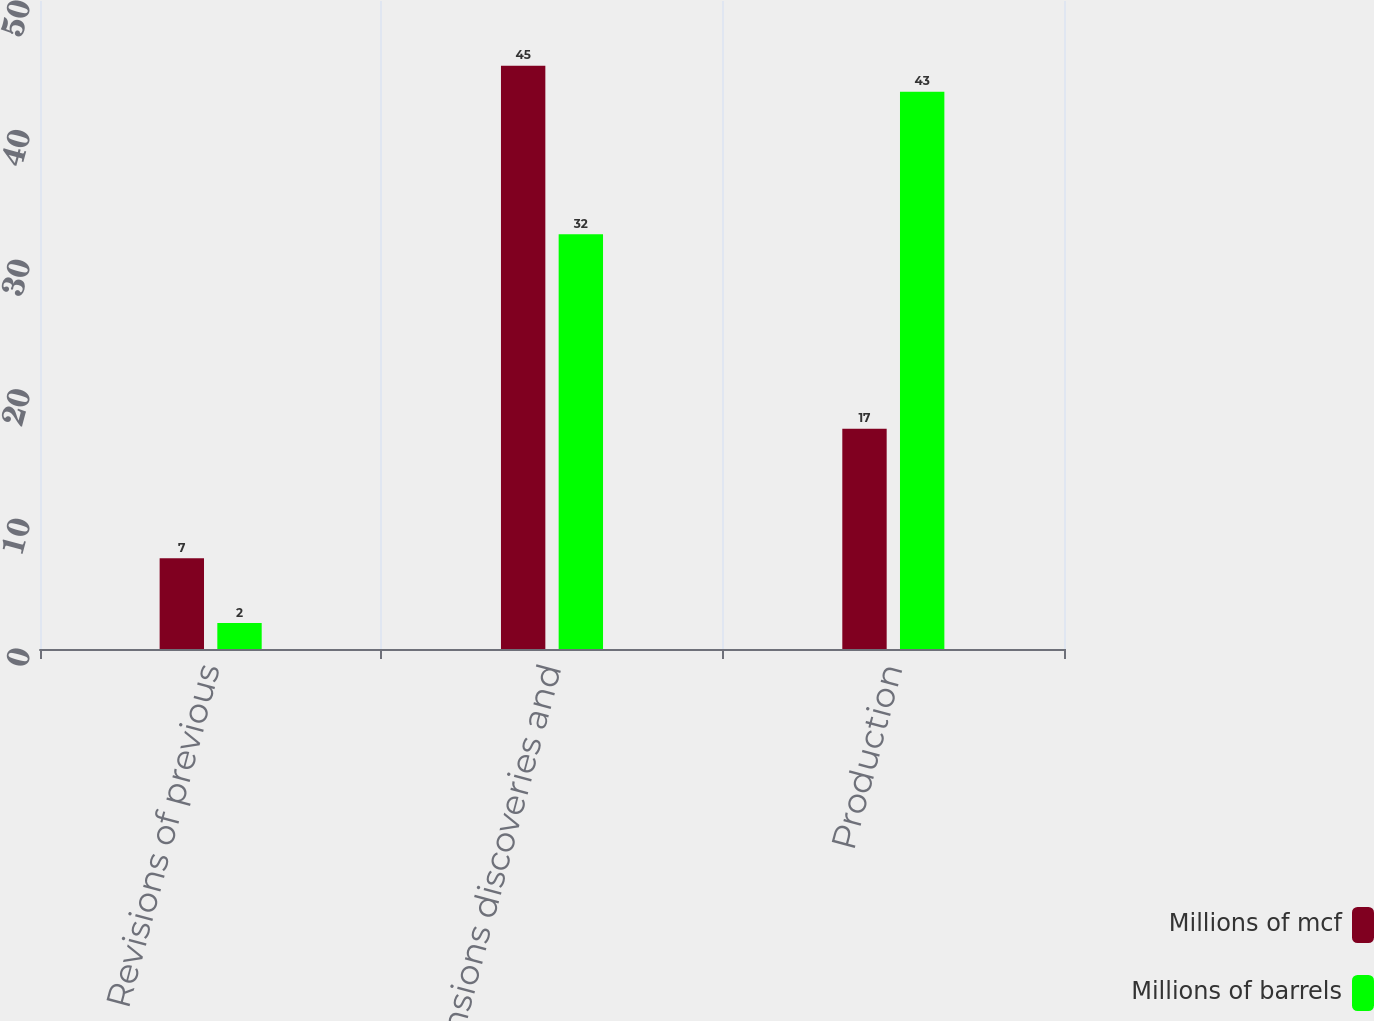<chart> <loc_0><loc_0><loc_500><loc_500><stacked_bar_chart><ecel><fcel>Revisions of previous<fcel>Extensions discoveries and<fcel>Production<nl><fcel>Millions of mcf<fcel>7<fcel>45<fcel>17<nl><fcel>Millions of barrels<fcel>2<fcel>32<fcel>43<nl></chart> 